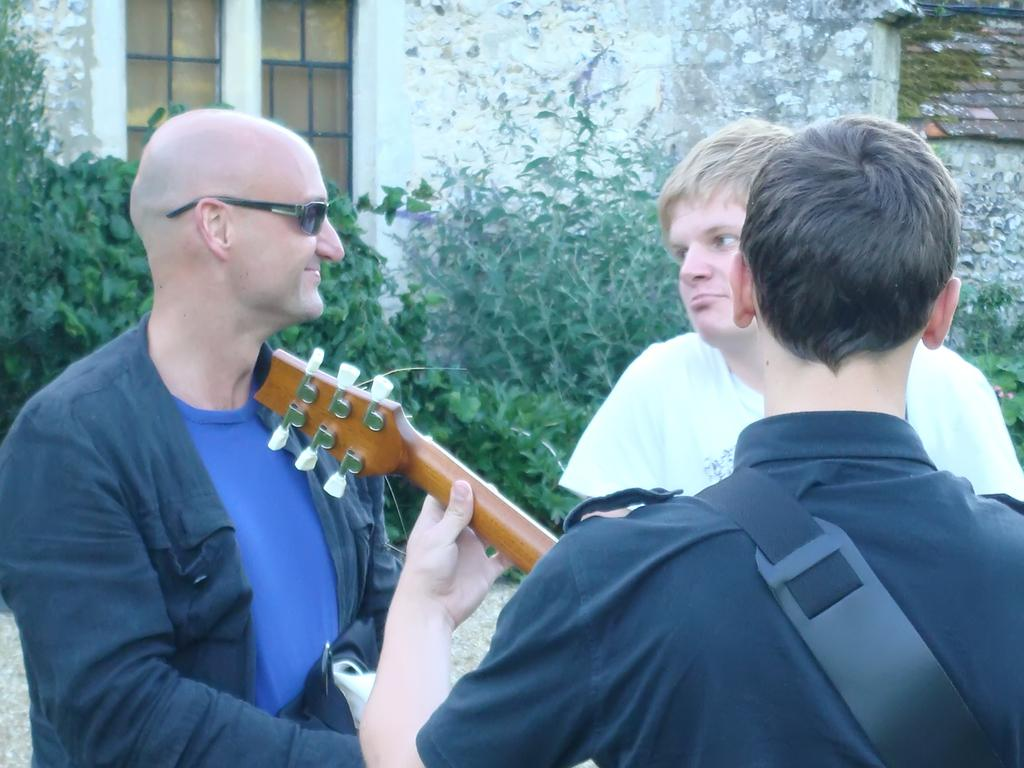How many people are in the image? There are three persons in the image. What is the person on the left wearing? The person on the left is wearing goggles. What is the person with goggles holding? The person with goggles is holding a guitar. What can be seen in the background of the image? There are plants visible in the background of the image. What architectural features are present in the image? There is a window and a wall in the image. What type of leather is the person wearing in the image? There is no leather visible in the image; the person is wearing goggles and holding a guitar. How many times does the person jump in the image? There is no jumping depicted in the image; the person is holding a guitar. 